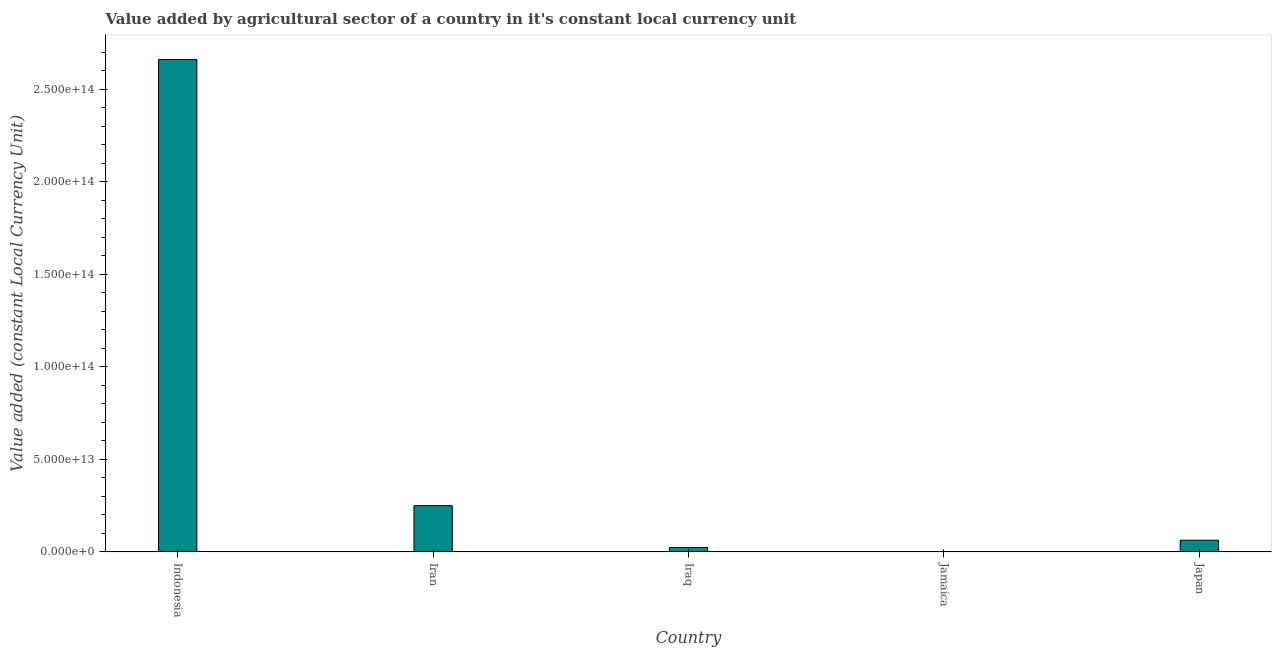Does the graph contain any zero values?
Provide a short and direct response. No. Does the graph contain grids?
Provide a short and direct response. No. What is the title of the graph?
Ensure brevity in your answer.  Value added by agricultural sector of a country in it's constant local currency unit. What is the label or title of the X-axis?
Ensure brevity in your answer.  Country. What is the label or title of the Y-axis?
Provide a succinct answer. Value added (constant Local Currency Unit). What is the value added by agriculture sector in Indonesia?
Keep it short and to the point. 2.66e+14. Across all countries, what is the maximum value added by agriculture sector?
Make the answer very short. 2.66e+14. Across all countries, what is the minimum value added by agriculture sector?
Keep it short and to the point. 4.03e+1. In which country was the value added by agriculture sector minimum?
Your response must be concise. Jamaica. What is the sum of the value added by agriculture sector?
Make the answer very short. 3.00e+14. What is the difference between the value added by agriculture sector in Indonesia and Iraq?
Your answer should be compact. 2.64e+14. What is the average value added by agriculture sector per country?
Provide a short and direct response. 6.00e+13. What is the median value added by agriculture sector?
Provide a short and direct response. 6.30e+12. In how many countries, is the value added by agriculture sector greater than 110000000000000 LCU?
Your answer should be very brief. 1. What is the ratio of the value added by agriculture sector in Iran to that in Iraq?
Offer a very short reply. 10.57. What is the difference between the highest and the second highest value added by agriculture sector?
Your answer should be very brief. 2.41e+14. What is the difference between the highest and the lowest value added by agriculture sector?
Your answer should be very brief. 2.66e+14. In how many countries, is the value added by agriculture sector greater than the average value added by agriculture sector taken over all countries?
Offer a very short reply. 1. What is the difference between two consecutive major ticks on the Y-axis?
Provide a succinct answer. 5.00e+13. What is the Value added (constant Local Currency Unit) of Indonesia?
Give a very brief answer. 2.66e+14. What is the Value added (constant Local Currency Unit) in Iran?
Your response must be concise. 2.50e+13. What is the Value added (constant Local Currency Unit) in Iraq?
Make the answer very short. 2.36e+12. What is the Value added (constant Local Currency Unit) of Jamaica?
Provide a succinct answer. 4.03e+1. What is the Value added (constant Local Currency Unit) of Japan?
Make the answer very short. 6.30e+12. What is the difference between the Value added (constant Local Currency Unit) in Indonesia and Iran?
Offer a very short reply. 2.41e+14. What is the difference between the Value added (constant Local Currency Unit) in Indonesia and Iraq?
Provide a short and direct response. 2.64e+14. What is the difference between the Value added (constant Local Currency Unit) in Indonesia and Jamaica?
Ensure brevity in your answer.  2.66e+14. What is the difference between the Value added (constant Local Currency Unit) in Indonesia and Japan?
Offer a very short reply. 2.60e+14. What is the difference between the Value added (constant Local Currency Unit) in Iran and Iraq?
Provide a succinct answer. 2.26e+13. What is the difference between the Value added (constant Local Currency Unit) in Iran and Jamaica?
Give a very brief answer. 2.49e+13. What is the difference between the Value added (constant Local Currency Unit) in Iran and Japan?
Your response must be concise. 1.87e+13. What is the difference between the Value added (constant Local Currency Unit) in Iraq and Jamaica?
Ensure brevity in your answer.  2.32e+12. What is the difference between the Value added (constant Local Currency Unit) in Iraq and Japan?
Offer a terse response. -3.93e+12. What is the difference between the Value added (constant Local Currency Unit) in Jamaica and Japan?
Provide a succinct answer. -6.26e+12. What is the ratio of the Value added (constant Local Currency Unit) in Indonesia to that in Iran?
Offer a terse response. 10.66. What is the ratio of the Value added (constant Local Currency Unit) in Indonesia to that in Iraq?
Provide a succinct answer. 112.61. What is the ratio of the Value added (constant Local Currency Unit) in Indonesia to that in Jamaica?
Provide a succinct answer. 6602.36. What is the ratio of the Value added (constant Local Currency Unit) in Indonesia to that in Japan?
Offer a very short reply. 42.27. What is the ratio of the Value added (constant Local Currency Unit) in Iran to that in Iraq?
Give a very brief answer. 10.57. What is the ratio of the Value added (constant Local Currency Unit) in Iran to that in Jamaica?
Your answer should be very brief. 619.54. What is the ratio of the Value added (constant Local Currency Unit) in Iran to that in Japan?
Your answer should be compact. 3.97. What is the ratio of the Value added (constant Local Currency Unit) in Iraq to that in Jamaica?
Your answer should be compact. 58.63. What is the ratio of the Value added (constant Local Currency Unit) in Iraq to that in Japan?
Provide a short and direct response. 0.38. What is the ratio of the Value added (constant Local Currency Unit) in Jamaica to that in Japan?
Your answer should be compact. 0.01. 